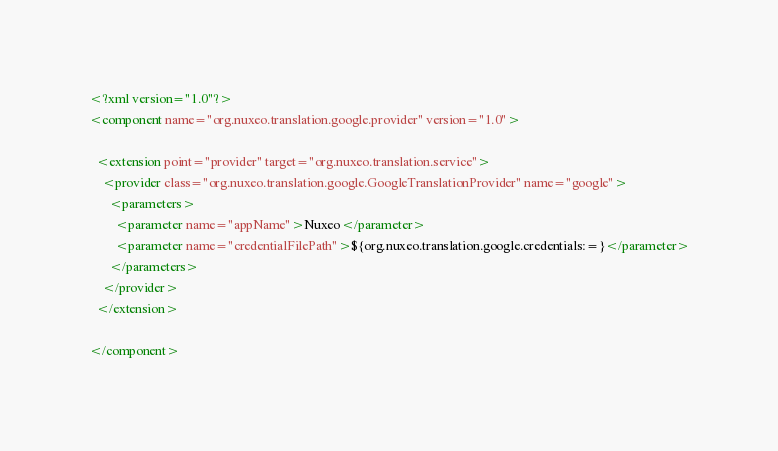Convert code to text. <code><loc_0><loc_0><loc_500><loc_500><_XML_><?xml version="1.0"?>
<component name="org.nuxeo.translation.google.provider" version="1.0">

  <extension point="provider" target="org.nuxeo.translation.service">
    <provider class="org.nuxeo.translation.google.GoogleTranslationProvider" name="google">
      <parameters>
        <parameter name="appName">Nuxeo</parameter>
        <parameter name="credentialFilePath">${org.nuxeo.translation.google.credentials:=}</parameter>
      </parameters>
    </provider>
  </extension>

</component>
</code> 